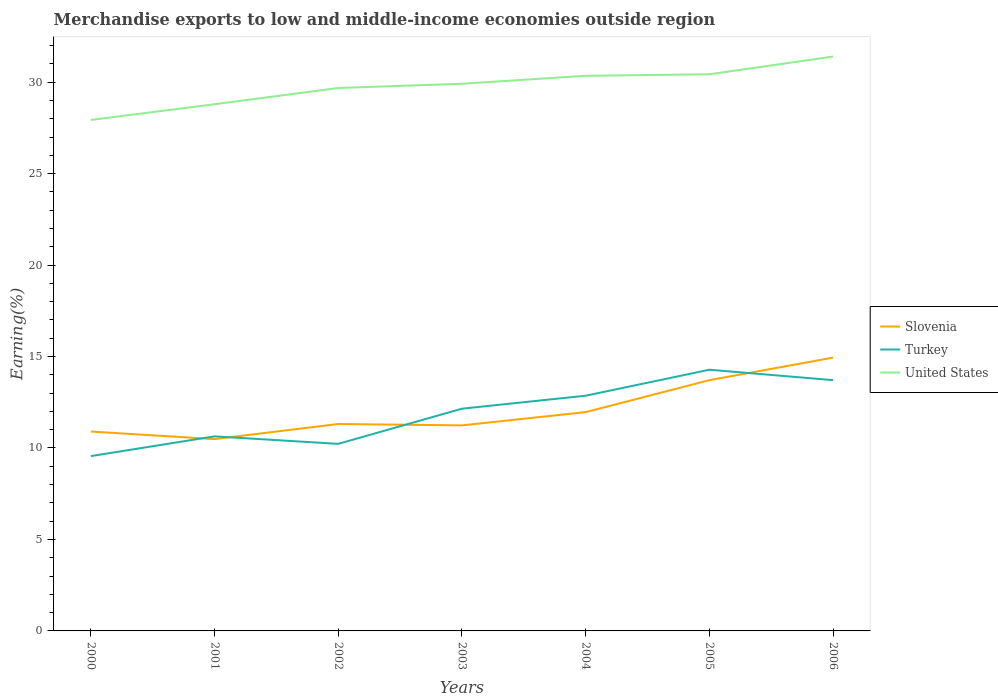Does the line corresponding to United States intersect with the line corresponding to Turkey?
Make the answer very short. No. Is the number of lines equal to the number of legend labels?
Give a very brief answer. Yes. Across all years, what is the maximum percentage of amount earned from merchandise exports in Slovenia?
Offer a very short reply. 10.49. What is the total percentage of amount earned from merchandise exports in Slovenia in the graph?
Provide a succinct answer. -0.75. What is the difference between the highest and the second highest percentage of amount earned from merchandise exports in Turkey?
Ensure brevity in your answer.  4.72. Is the percentage of amount earned from merchandise exports in Turkey strictly greater than the percentage of amount earned from merchandise exports in United States over the years?
Make the answer very short. Yes. Are the values on the major ticks of Y-axis written in scientific E-notation?
Your response must be concise. No. Does the graph contain any zero values?
Your response must be concise. No. What is the title of the graph?
Provide a succinct answer. Merchandise exports to low and middle-income economies outside region. Does "Finland" appear as one of the legend labels in the graph?
Offer a terse response. No. What is the label or title of the X-axis?
Your answer should be very brief. Years. What is the label or title of the Y-axis?
Provide a succinct answer. Earning(%). What is the Earning(%) of Slovenia in 2000?
Your answer should be compact. 10.9. What is the Earning(%) in Turkey in 2000?
Ensure brevity in your answer.  9.56. What is the Earning(%) in United States in 2000?
Your response must be concise. 27.93. What is the Earning(%) in Slovenia in 2001?
Offer a very short reply. 10.49. What is the Earning(%) of Turkey in 2001?
Ensure brevity in your answer.  10.64. What is the Earning(%) of United States in 2001?
Provide a short and direct response. 28.79. What is the Earning(%) of Slovenia in 2002?
Your answer should be very brief. 11.31. What is the Earning(%) in Turkey in 2002?
Your answer should be very brief. 10.23. What is the Earning(%) of United States in 2002?
Offer a very short reply. 29.68. What is the Earning(%) in Slovenia in 2003?
Offer a terse response. 11.24. What is the Earning(%) of Turkey in 2003?
Make the answer very short. 12.15. What is the Earning(%) of United States in 2003?
Your response must be concise. 29.91. What is the Earning(%) of Slovenia in 2004?
Ensure brevity in your answer.  11.96. What is the Earning(%) in Turkey in 2004?
Give a very brief answer. 12.86. What is the Earning(%) in United States in 2004?
Your answer should be very brief. 30.35. What is the Earning(%) of Slovenia in 2005?
Provide a short and direct response. 13.71. What is the Earning(%) in Turkey in 2005?
Ensure brevity in your answer.  14.28. What is the Earning(%) of United States in 2005?
Make the answer very short. 30.43. What is the Earning(%) of Slovenia in 2006?
Your response must be concise. 14.94. What is the Earning(%) in Turkey in 2006?
Provide a succinct answer. 13.71. What is the Earning(%) in United States in 2006?
Ensure brevity in your answer.  31.4. Across all years, what is the maximum Earning(%) of Slovenia?
Your answer should be compact. 14.94. Across all years, what is the maximum Earning(%) in Turkey?
Offer a very short reply. 14.28. Across all years, what is the maximum Earning(%) in United States?
Your answer should be very brief. 31.4. Across all years, what is the minimum Earning(%) of Slovenia?
Provide a short and direct response. 10.49. Across all years, what is the minimum Earning(%) of Turkey?
Give a very brief answer. 9.56. Across all years, what is the minimum Earning(%) in United States?
Make the answer very short. 27.93. What is the total Earning(%) in Slovenia in the graph?
Provide a short and direct response. 84.55. What is the total Earning(%) of Turkey in the graph?
Offer a very short reply. 83.41. What is the total Earning(%) in United States in the graph?
Make the answer very short. 208.49. What is the difference between the Earning(%) in Slovenia in 2000 and that in 2001?
Make the answer very short. 0.41. What is the difference between the Earning(%) in Turkey in 2000 and that in 2001?
Your answer should be compact. -1.08. What is the difference between the Earning(%) in United States in 2000 and that in 2001?
Give a very brief answer. -0.86. What is the difference between the Earning(%) in Slovenia in 2000 and that in 2002?
Offer a terse response. -0.41. What is the difference between the Earning(%) of Turkey in 2000 and that in 2002?
Provide a succinct answer. -0.67. What is the difference between the Earning(%) in United States in 2000 and that in 2002?
Your answer should be very brief. -1.75. What is the difference between the Earning(%) of Slovenia in 2000 and that in 2003?
Offer a very short reply. -0.34. What is the difference between the Earning(%) in Turkey in 2000 and that in 2003?
Provide a succinct answer. -2.59. What is the difference between the Earning(%) in United States in 2000 and that in 2003?
Make the answer very short. -1.98. What is the difference between the Earning(%) in Slovenia in 2000 and that in 2004?
Provide a succinct answer. -1.06. What is the difference between the Earning(%) of Turkey in 2000 and that in 2004?
Offer a terse response. -3.3. What is the difference between the Earning(%) of United States in 2000 and that in 2004?
Your response must be concise. -2.41. What is the difference between the Earning(%) in Slovenia in 2000 and that in 2005?
Give a very brief answer. -2.81. What is the difference between the Earning(%) of Turkey in 2000 and that in 2005?
Provide a short and direct response. -4.72. What is the difference between the Earning(%) in United States in 2000 and that in 2005?
Keep it short and to the point. -2.49. What is the difference between the Earning(%) of Slovenia in 2000 and that in 2006?
Your answer should be very brief. -4.04. What is the difference between the Earning(%) in Turkey in 2000 and that in 2006?
Your response must be concise. -4.15. What is the difference between the Earning(%) in United States in 2000 and that in 2006?
Your response must be concise. -3.46. What is the difference between the Earning(%) of Slovenia in 2001 and that in 2002?
Offer a very short reply. -0.83. What is the difference between the Earning(%) in Turkey in 2001 and that in 2002?
Provide a succinct answer. 0.41. What is the difference between the Earning(%) of United States in 2001 and that in 2002?
Keep it short and to the point. -0.89. What is the difference between the Earning(%) in Slovenia in 2001 and that in 2003?
Offer a terse response. -0.75. What is the difference between the Earning(%) of Turkey in 2001 and that in 2003?
Your response must be concise. -1.51. What is the difference between the Earning(%) in United States in 2001 and that in 2003?
Provide a succinct answer. -1.12. What is the difference between the Earning(%) of Slovenia in 2001 and that in 2004?
Provide a short and direct response. -1.48. What is the difference between the Earning(%) in Turkey in 2001 and that in 2004?
Give a very brief answer. -2.22. What is the difference between the Earning(%) of United States in 2001 and that in 2004?
Your answer should be compact. -1.55. What is the difference between the Earning(%) of Slovenia in 2001 and that in 2005?
Your answer should be compact. -3.22. What is the difference between the Earning(%) of Turkey in 2001 and that in 2005?
Ensure brevity in your answer.  -3.64. What is the difference between the Earning(%) of United States in 2001 and that in 2005?
Your response must be concise. -1.64. What is the difference between the Earning(%) in Slovenia in 2001 and that in 2006?
Make the answer very short. -4.46. What is the difference between the Earning(%) in Turkey in 2001 and that in 2006?
Provide a succinct answer. -3.07. What is the difference between the Earning(%) in United States in 2001 and that in 2006?
Provide a succinct answer. -2.61. What is the difference between the Earning(%) in Slovenia in 2002 and that in 2003?
Keep it short and to the point. 0.08. What is the difference between the Earning(%) of Turkey in 2002 and that in 2003?
Provide a short and direct response. -1.92. What is the difference between the Earning(%) in United States in 2002 and that in 2003?
Make the answer very short. -0.23. What is the difference between the Earning(%) of Slovenia in 2002 and that in 2004?
Keep it short and to the point. -0.65. What is the difference between the Earning(%) of Turkey in 2002 and that in 2004?
Your answer should be compact. -2.63. What is the difference between the Earning(%) of United States in 2002 and that in 2004?
Your answer should be compact. -0.67. What is the difference between the Earning(%) in Slovenia in 2002 and that in 2005?
Provide a short and direct response. -2.4. What is the difference between the Earning(%) of Turkey in 2002 and that in 2005?
Give a very brief answer. -4.05. What is the difference between the Earning(%) of United States in 2002 and that in 2005?
Keep it short and to the point. -0.75. What is the difference between the Earning(%) of Slovenia in 2002 and that in 2006?
Your answer should be compact. -3.63. What is the difference between the Earning(%) of Turkey in 2002 and that in 2006?
Your response must be concise. -3.48. What is the difference between the Earning(%) of United States in 2002 and that in 2006?
Your response must be concise. -1.72. What is the difference between the Earning(%) of Slovenia in 2003 and that in 2004?
Your answer should be very brief. -0.72. What is the difference between the Earning(%) in Turkey in 2003 and that in 2004?
Keep it short and to the point. -0.71. What is the difference between the Earning(%) of United States in 2003 and that in 2004?
Offer a very short reply. -0.43. What is the difference between the Earning(%) of Slovenia in 2003 and that in 2005?
Your answer should be very brief. -2.47. What is the difference between the Earning(%) of Turkey in 2003 and that in 2005?
Provide a succinct answer. -2.13. What is the difference between the Earning(%) of United States in 2003 and that in 2005?
Give a very brief answer. -0.52. What is the difference between the Earning(%) in Slovenia in 2003 and that in 2006?
Ensure brevity in your answer.  -3.71. What is the difference between the Earning(%) in Turkey in 2003 and that in 2006?
Provide a succinct answer. -1.56. What is the difference between the Earning(%) in United States in 2003 and that in 2006?
Keep it short and to the point. -1.49. What is the difference between the Earning(%) of Slovenia in 2004 and that in 2005?
Offer a very short reply. -1.75. What is the difference between the Earning(%) in Turkey in 2004 and that in 2005?
Give a very brief answer. -1.42. What is the difference between the Earning(%) in United States in 2004 and that in 2005?
Offer a terse response. -0.08. What is the difference between the Earning(%) of Slovenia in 2004 and that in 2006?
Give a very brief answer. -2.98. What is the difference between the Earning(%) of Turkey in 2004 and that in 2006?
Offer a very short reply. -0.85. What is the difference between the Earning(%) of United States in 2004 and that in 2006?
Your response must be concise. -1.05. What is the difference between the Earning(%) in Slovenia in 2005 and that in 2006?
Offer a very short reply. -1.23. What is the difference between the Earning(%) in Turkey in 2005 and that in 2006?
Provide a succinct answer. 0.57. What is the difference between the Earning(%) in United States in 2005 and that in 2006?
Make the answer very short. -0.97. What is the difference between the Earning(%) of Slovenia in 2000 and the Earning(%) of Turkey in 2001?
Offer a terse response. 0.26. What is the difference between the Earning(%) of Slovenia in 2000 and the Earning(%) of United States in 2001?
Provide a short and direct response. -17.89. What is the difference between the Earning(%) in Turkey in 2000 and the Earning(%) in United States in 2001?
Ensure brevity in your answer.  -19.23. What is the difference between the Earning(%) of Slovenia in 2000 and the Earning(%) of Turkey in 2002?
Provide a short and direct response. 0.67. What is the difference between the Earning(%) in Slovenia in 2000 and the Earning(%) in United States in 2002?
Your answer should be very brief. -18.78. What is the difference between the Earning(%) of Turkey in 2000 and the Earning(%) of United States in 2002?
Make the answer very short. -20.12. What is the difference between the Earning(%) in Slovenia in 2000 and the Earning(%) in Turkey in 2003?
Make the answer very short. -1.25. What is the difference between the Earning(%) of Slovenia in 2000 and the Earning(%) of United States in 2003?
Keep it short and to the point. -19.01. What is the difference between the Earning(%) of Turkey in 2000 and the Earning(%) of United States in 2003?
Offer a very short reply. -20.36. What is the difference between the Earning(%) of Slovenia in 2000 and the Earning(%) of Turkey in 2004?
Your response must be concise. -1.96. What is the difference between the Earning(%) of Slovenia in 2000 and the Earning(%) of United States in 2004?
Keep it short and to the point. -19.45. What is the difference between the Earning(%) of Turkey in 2000 and the Earning(%) of United States in 2004?
Offer a very short reply. -20.79. What is the difference between the Earning(%) in Slovenia in 2000 and the Earning(%) in Turkey in 2005?
Your answer should be compact. -3.38. What is the difference between the Earning(%) in Slovenia in 2000 and the Earning(%) in United States in 2005?
Your answer should be compact. -19.53. What is the difference between the Earning(%) of Turkey in 2000 and the Earning(%) of United States in 2005?
Keep it short and to the point. -20.87. What is the difference between the Earning(%) of Slovenia in 2000 and the Earning(%) of Turkey in 2006?
Ensure brevity in your answer.  -2.81. What is the difference between the Earning(%) of Slovenia in 2000 and the Earning(%) of United States in 2006?
Give a very brief answer. -20.5. What is the difference between the Earning(%) of Turkey in 2000 and the Earning(%) of United States in 2006?
Provide a succinct answer. -21.84. What is the difference between the Earning(%) in Slovenia in 2001 and the Earning(%) in Turkey in 2002?
Offer a very short reply. 0.26. What is the difference between the Earning(%) in Slovenia in 2001 and the Earning(%) in United States in 2002?
Ensure brevity in your answer.  -19.19. What is the difference between the Earning(%) of Turkey in 2001 and the Earning(%) of United States in 2002?
Your response must be concise. -19.04. What is the difference between the Earning(%) of Slovenia in 2001 and the Earning(%) of Turkey in 2003?
Make the answer very short. -1.66. What is the difference between the Earning(%) in Slovenia in 2001 and the Earning(%) in United States in 2003?
Ensure brevity in your answer.  -19.43. What is the difference between the Earning(%) of Turkey in 2001 and the Earning(%) of United States in 2003?
Keep it short and to the point. -19.28. What is the difference between the Earning(%) in Slovenia in 2001 and the Earning(%) in Turkey in 2004?
Provide a succinct answer. -2.37. What is the difference between the Earning(%) in Slovenia in 2001 and the Earning(%) in United States in 2004?
Give a very brief answer. -19.86. What is the difference between the Earning(%) in Turkey in 2001 and the Earning(%) in United States in 2004?
Give a very brief answer. -19.71. What is the difference between the Earning(%) in Slovenia in 2001 and the Earning(%) in Turkey in 2005?
Give a very brief answer. -3.79. What is the difference between the Earning(%) of Slovenia in 2001 and the Earning(%) of United States in 2005?
Offer a terse response. -19.94. What is the difference between the Earning(%) of Turkey in 2001 and the Earning(%) of United States in 2005?
Make the answer very short. -19.79. What is the difference between the Earning(%) in Slovenia in 2001 and the Earning(%) in Turkey in 2006?
Make the answer very short. -3.22. What is the difference between the Earning(%) of Slovenia in 2001 and the Earning(%) of United States in 2006?
Your answer should be very brief. -20.91. What is the difference between the Earning(%) of Turkey in 2001 and the Earning(%) of United States in 2006?
Ensure brevity in your answer.  -20.76. What is the difference between the Earning(%) of Slovenia in 2002 and the Earning(%) of Turkey in 2003?
Offer a terse response. -0.84. What is the difference between the Earning(%) in Slovenia in 2002 and the Earning(%) in United States in 2003?
Ensure brevity in your answer.  -18.6. What is the difference between the Earning(%) of Turkey in 2002 and the Earning(%) of United States in 2003?
Make the answer very short. -19.69. What is the difference between the Earning(%) in Slovenia in 2002 and the Earning(%) in Turkey in 2004?
Your answer should be compact. -1.55. What is the difference between the Earning(%) in Slovenia in 2002 and the Earning(%) in United States in 2004?
Ensure brevity in your answer.  -19.03. What is the difference between the Earning(%) in Turkey in 2002 and the Earning(%) in United States in 2004?
Ensure brevity in your answer.  -20.12. What is the difference between the Earning(%) in Slovenia in 2002 and the Earning(%) in Turkey in 2005?
Your response must be concise. -2.97. What is the difference between the Earning(%) of Slovenia in 2002 and the Earning(%) of United States in 2005?
Ensure brevity in your answer.  -19.12. What is the difference between the Earning(%) in Turkey in 2002 and the Earning(%) in United States in 2005?
Provide a succinct answer. -20.2. What is the difference between the Earning(%) in Slovenia in 2002 and the Earning(%) in Turkey in 2006?
Your response must be concise. -2.4. What is the difference between the Earning(%) in Slovenia in 2002 and the Earning(%) in United States in 2006?
Provide a succinct answer. -20.09. What is the difference between the Earning(%) in Turkey in 2002 and the Earning(%) in United States in 2006?
Offer a very short reply. -21.17. What is the difference between the Earning(%) in Slovenia in 2003 and the Earning(%) in Turkey in 2004?
Give a very brief answer. -1.62. What is the difference between the Earning(%) of Slovenia in 2003 and the Earning(%) of United States in 2004?
Your response must be concise. -19.11. What is the difference between the Earning(%) of Turkey in 2003 and the Earning(%) of United States in 2004?
Give a very brief answer. -18.2. What is the difference between the Earning(%) in Slovenia in 2003 and the Earning(%) in Turkey in 2005?
Your response must be concise. -3.04. What is the difference between the Earning(%) in Slovenia in 2003 and the Earning(%) in United States in 2005?
Your response must be concise. -19.19. What is the difference between the Earning(%) of Turkey in 2003 and the Earning(%) of United States in 2005?
Provide a short and direct response. -18.28. What is the difference between the Earning(%) of Slovenia in 2003 and the Earning(%) of Turkey in 2006?
Give a very brief answer. -2.47. What is the difference between the Earning(%) in Slovenia in 2003 and the Earning(%) in United States in 2006?
Offer a very short reply. -20.16. What is the difference between the Earning(%) in Turkey in 2003 and the Earning(%) in United States in 2006?
Keep it short and to the point. -19.25. What is the difference between the Earning(%) in Slovenia in 2004 and the Earning(%) in Turkey in 2005?
Your response must be concise. -2.32. What is the difference between the Earning(%) of Slovenia in 2004 and the Earning(%) of United States in 2005?
Your response must be concise. -18.47. What is the difference between the Earning(%) of Turkey in 2004 and the Earning(%) of United States in 2005?
Give a very brief answer. -17.57. What is the difference between the Earning(%) in Slovenia in 2004 and the Earning(%) in Turkey in 2006?
Offer a very short reply. -1.75. What is the difference between the Earning(%) of Slovenia in 2004 and the Earning(%) of United States in 2006?
Your response must be concise. -19.44. What is the difference between the Earning(%) in Turkey in 2004 and the Earning(%) in United States in 2006?
Ensure brevity in your answer.  -18.54. What is the difference between the Earning(%) of Slovenia in 2005 and the Earning(%) of United States in 2006?
Give a very brief answer. -17.69. What is the difference between the Earning(%) of Turkey in 2005 and the Earning(%) of United States in 2006?
Provide a succinct answer. -17.12. What is the average Earning(%) of Slovenia per year?
Your answer should be very brief. 12.08. What is the average Earning(%) in Turkey per year?
Make the answer very short. 11.92. What is the average Earning(%) in United States per year?
Your answer should be very brief. 29.78. In the year 2000, what is the difference between the Earning(%) in Slovenia and Earning(%) in Turkey?
Make the answer very short. 1.34. In the year 2000, what is the difference between the Earning(%) in Slovenia and Earning(%) in United States?
Ensure brevity in your answer.  -17.03. In the year 2000, what is the difference between the Earning(%) of Turkey and Earning(%) of United States?
Make the answer very short. -18.38. In the year 2001, what is the difference between the Earning(%) in Slovenia and Earning(%) in Turkey?
Your response must be concise. -0.15. In the year 2001, what is the difference between the Earning(%) in Slovenia and Earning(%) in United States?
Give a very brief answer. -18.31. In the year 2001, what is the difference between the Earning(%) in Turkey and Earning(%) in United States?
Provide a succinct answer. -18.16. In the year 2002, what is the difference between the Earning(%) in Slovenia and Earning(%) in Turkey?
Your response must be concise. 1.09. In the year 2002, what is the difference between the Earning(%) in Slovenia and Earning(%) in United States?
Ensure brevity in your answer.  -18.37. In the year 2002, what is the difference between the Earning(%) of Turkey and Earning(%) of United States?
Make the answer very short. -19.45. In the year 2003, what is the difference between the Earning(%) of Slovenia and Earning(%) of Turkey?
Your response must be concise. -0.91. In the year 2003, what is the difference between the Earning(%) in Slovenia and Earning(%) in United States?
Your answer should be compact. -18.68. In the year 2003, what is the difference between the Earning(%) of Turkey and Earning(%) of United States?
Offer a terse response. -17.76. In the year 2004, what is the difference between the Earning(%) in Slovenia and Earning(%) in Turkey?
Your answer should be very brief. -0.9. In the year 2004, what is the difference between the Earning(%) in Slovenia and Earning(%) in United States?
Provide a short and direct response. -18.38. In the year 2004, what is the difference between the Earning(%) in Turkey and Earning(%) in United States?
Offer a terse response. -17.49. In the year 2005, what is the difference between the Earning(%) of Slovenia and Earning(%) of Turkey?
Your answer should be very brief. -0.57. In the year 2005, what is the difference between the Earning(%) in Slovenia and Earning(%) in United States?
Offer a terse response. -16.72. In the year 2005, what is the difference between the Earning(%) of Turkey and Earning(%) of United States?
Make the answer very short. -16.15. In the year 2006, what is the difference between the Earning(%) of Slovenia and Earning(%) of Turkey?
Offer a terse response. 1.23. In the year 2006, what is the difference between the Earning(%) in Slovenia and Earning(%) in United States?
Ensure brevity in your answer.  -16.46. In the year 2006, what is the difference between the Earning(%) of Turkey and Earning(%) of United States?
Offer a very short reply. -17.69. What is the ratio of the Earning(%) in Slovenia in 2000 to that in 2001?
Offer a terse response. 1.04. What is the ratio of the Earning(%) in Turkey in 2000 to that in 2001?
Offer a very short reply. 0.9. What is the ratio of the Earning(%) of United States in 2000 to that in 2001?
Your answer should be very brief. 0.97. What is the ratio of the Earning(%) in Slovenia in 2000 to that in 2002?
Give a very brief answer. 0.96. What is the ratio of the Earning(%) of Turkey in 2000 to that in 2002?
Give a very brief answer. 0.93. What is the ratio of the Earning(%) of Slovenia in 2000 to that in 2003?
Provide a short and direct response. 0.97. What is the ratio of the Earning(%) in Turkey in 2000 to that in 2003?
Your answer should be very brief. 0.79. What is the ratio of the Earning(%) in United States in 2000 to that in 2003?
Make the answer very short. 0.93. What is the ratio of the Earning(%) in Slovenia in 2000 to that in 2004?
Your answer should be compact. 0.91. What is the ratio of the Earning(%) in Turkey in 2000 to that in 2004?
Make the answer very short. 0.74. What is the ratio of the Earning(%) of United States in 2000 to that in 2004?
Your answer should be very brief. 0.92. What is the ratio of the Earning(%) of Slovenia in 2000 to that in 2005?
Offer a terse response. 0.8. What is the ratio of the Earning(%) in Turkey in 2000 to that in 2005?
Ensure brevity in your answer.  0.67. What is the ratio of the Earning(%) of United States in 2000 to that in 2005?
Provide a succinct answer. 0.92. What is the ratio of the Earning(%) in Slovenia in 2000 to that in 2006?
Make the answer very short. 0.73. What is the ratio of the Earning(%) of Turkey in 2000 to that in 2006?
Offer a very short reply. 0.7. What is the ratio of the Earning(%) in United States in 2000 to that in 2006?
Ensure brevity in your answer.  0.89. What is the ratio of the Earning(%) of Slovenia in 2001 to that in 2002?
Your response must be concise. 0.93. What is the ratio of the Earning(%) of Turkey in 2001 to that in 2002?
Provide a succinct answer. 1.04. What is the ratio of the Earning(%) of United States in 2001 to that in 2002?
Offer a terse response. 0.97. What is the ratio of the Earning(%) in Slovenia in 2001 to that in 2003?
Give a very brief answer. 0.93. What is the ratio of the Earning(%) in Turkey in 2001 to that in 2003?
Your answer should be compact. 0.88. What is the ratio of the Earning(%) of United States in 2001 to that in 2003?
Your response must be concise. 0.96. What is the ratio of the Earning(%) of Slovenia in 2001 to that in 2004?
Give a very brief answer. 0.88. What is the ratio of the Earning(%) in Turkey in 2001 to that in 2004?
Your response must be concise. 0.83. What is the ratio of the Earning(%) of United States in 2001 to that in 2004?
Give a very brief answer. 0.95. What is the ratio of the Earning(%) in Slovenia in 2001 to that in 2005?
Give a very brief answer. 0.76. What is the ratio of the Earning(%) in Turkey in 2001 to that in 2005?
Give a very brief answer. 0.74. What is the ratio of the Earning(%) in United States in 2001 to that in 2005?
Provide a short and direct response. 0.95. What is the ratio of the Earning(%) in Slovenia in 2001 to that in 2006?
Your response must be concise. 0.7. What is the ratio of the Earning(%) in Turkey in 2001 to that in 2006?
Keep it short and to the point. 0.78. What is the ratio of the Earning(%) in United States in 2001 to that in 2006?
Your response must be concise. 0.92. What is the ratio of the Earning(%) in Slovenia in 2002 to that in 2003?
Offer a terse response. 1.01. What is the ratio of the Earning(%) in Turkey in 2002 to that in 2003?
Provide a succinct answer. 0.84. What is the ratio of the Earning(%) in United States in 2002 to that in 2003?
Make the answer very short. 0.99. What is the ratio of the Earning(%) in Slovenia in 2002 to that in 2004?
Offer a very short reply. 0.95. What is the ratio of the Earning(%) in Turkey in 2002 to that in 2004?
Make the answer very short. 0.8. What is the ratio of the Earning(%) of United States in 2002 to that in 2004?
Give a very brief answer. 0.98. What is the ratio of the Earning(%) in Slovenia in 2002 to that in 2005?
Offer a very short reply. 0.83. What is the ratio of the Earning(%) of Turkey in 2002 to that in 2005?
Your answer should be compact. 0.72. What is the ratio of the Earning(%) in United States in 2002 to that in 2005?
Your response must be concise. 0.98. What is the ratio of the Earning(%) of Slovenia in 2002 to that in 2006?
Offer a very short reply. 0.76. What is the ratio of the Earning(%) of Turkey in 2002 to that in 2006?
Provide a succinct answer. 0.75. What is the ratio of the Earning(%) of United States in 2002 to that in 2006?
Make the answer very short. 0.95. What is the ratio of the Earning(%) of Slovenia in 2003 to that in 2004?
Your answer should be compact. 0.94. What is the ratio of the Earning(%) of Turkey in 2003 to that in 2004?
Your answer should be compact. 0.94. What is the ratio of the Earning(%) in United States in 2003 to that in 2004?
Your answer should be compact. 0.99. What is the ratio of the Earning(%) in Slovenia in 2003 to that in 2005?
Provide a succinct answer. 0.82. What is the ratio of the Earning(%) of Turkey in 2003 to that in 2005?
Ensure brevity in your answer.  0.85. What is the ratio of the Earning(%) of United States in 2003 to that in 2005?
Offer a terse response. 0.98. What is the ratio of the Earning(%) in Slovenia in 2003 to that in 2006?
Your answer should be very brief. 0.75. What is the ratio of the Earning(%) of Turkey in 2003 to that in 2006?
Provide a short and direct response. 0.89. What is the ratio of the Earning(%) in United States in 2003 to that in 2006?
Give a very brief answer. 0.95. What is the ratio of the Earning(%) in Slovenia in 2004 to that in 2005?
Ensure brevity in your answer.  0.87. What is the ratio of the Earning(%) in Turkey in 2004 to that in 2005?
Offer a very short reply. 0.9. What is the ratio of the Earning(%) in Slovenia in 2004 to that in 2006?
Offer a terse response. 0.8. What is the ratio of the Earning(%) of Turkey in 2004 to that in 2006?
Offer a very short reply. 0.94. What is the ratio of the Earning(%) of United States in 2004 to that in 2006?
Your answer should be compact. 0.97. What is the ratio of the Earning(%) in Slovenia in 2005 to that in 2006?
Provide a succinct answer. 0.92. What is the ratio of the Earning(%) of Turkey in 2005 to that in 2006?
Offer a very short reply. 1.04. What is the ratio of the Earning(%) of United States in 2005 to that in 2006?
Your answer should be compact. 0.97. What is the difference between the highest and the second highest Earning(%) in Slovenia?
Your response must be concise. 1.23. What is the difference between the highest and the second highest Earning(%) of Turkey?
Keep it short and to the point. 0.57. What is the difference between the highest and the second highest Earning(%) of United States?
Your answer should be very brief. 0.97. What is the difference between the highest and the lowest Earning(%) of Slovenia?
Your answer should be compact. 4.46. What is the difference between the highest and the lowest Earning(%) of Turkey?
Your answer should be compact. 4.72. What is the difference between the highest and the lowest Earning(%) of United States?
Ensure brevity in your answer.  3.46. 